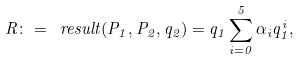<formula> <loc_0><loc_0><loc_500><loc_500>R \colon = \ r e s u l t ( P _ { 1 } , P _ { 2 } , q _ { 2 } ) = q _ { 1 } \sum _ { i = 0 } ^ { 5 } \alpha _ { i } q _ { 1 } ^ { i } ,</formula> 